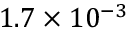Convert formula to latex. <formula><loc_0><loc_0><loc_500><loc_500>1 . 7 \times 1 0 ^ { - 3 }</formula> 